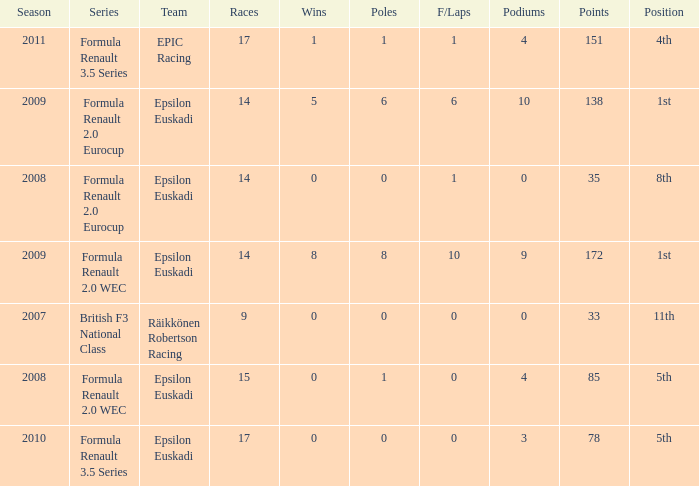Could you parse the entire table? {'header': ['Season', 'Series', 'Team', 'Races', 'Wins', 'Poles', 'F/Laps', 'Podiums', 'Points', 'Position'], 'rows': [['2011', 'Formula Renault 3.5 Series', 'EPIC Racing', '17', '1', '1', '1', '4', '151', '4th'], ['2009', 'Formula Renault 2.0 Eurocup', 'Epsilon Euskadi', '14', '5', '6', '6', '10', '138', '1st'], ['2008', 'Formula Renault 2.0 Eurocup', 'Epsilon Euskadi', '14', '0', '0', '1', '0', '35', '8th'], ['2009', 'Formula Renault 2.0 WEC', 'Epsilon Euskadi', '14', '8', '8', '10', '9', '172', '1st'], ['2007', 'British F3 National Class', 'Räikkönen Robertson Racing', '9', '0', '0', '0', '0', '33', '11th'], ['2008', 'Formula Renault 2.0 WEC', 'Epsilon Euskadi', '15', '0', '1', '0', '4', '85', '5th'], ['2010', 'Formula Renault 3.5 Series', 'Epsilon Euskadi', '17', '0', '0', '0', '3', '78', '5th']]} What team was he on when he finished in 11th position? Räikkönen Robertson Racing. 